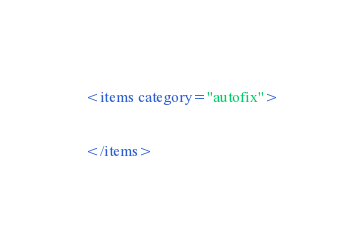Convert code to text. <code><loc_0><loc_0><loc_500><loc_500><_XML_>
<items category="autofix">


</items></code> 